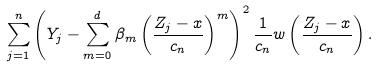Convert formula to latex. <formula><loc_0><loc_0><loc_500><loc_500>\sum _ { j = 1 } ^ { n } \left ( Y _ { j } - \sum _ { m = 0 } ^ { d } \beta _ { m } \left ( \frac { Z _ { j } - x } { c _ { n } } \right ) ^ { m } \right ) ^ { 2 } \frac { 1 } { c _ { n } } w \left ( \frac { Z _ { j } - x } { c _ { n } } \right ) .</formula> 